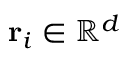<formula> <loc_0><loc_0><loc_500><loc_500>r _ { i } \in \mathbb { R } ^ { d }</formula> 